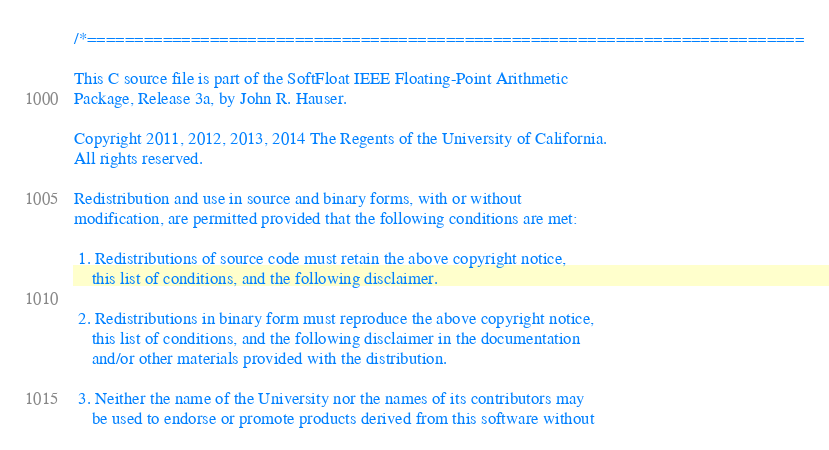Convert code to text. <code><loc_0><loc_0><loc_500><loc_500><_C_>
/*============================================================================

This C source file is part of the SoftFloat IEEE Floating-Point Arithmetic
Package, Release 3a, by John R. Hauser.

Copyright 2011, 2012, 2013, 2014 The Regents of the University of California.
All rights reserved.

Redistribution and use in source and binary forms, with or without
modification, are permitted provided that the following conditions are met:

 1. Redistributions of source code must retain the above copyright notice,
    this list of conditions, and the following disclaimer.

 2. Redistributions in binary form must reproduce the above copyright notice,
    this list of conditions, and the following disclaimer in the documentation
    and/or other materials provided with the distribution.

 3. Neither the name of the University nor the names of its contributors may
    be used to endorse or promote products derived from this software without</code> 